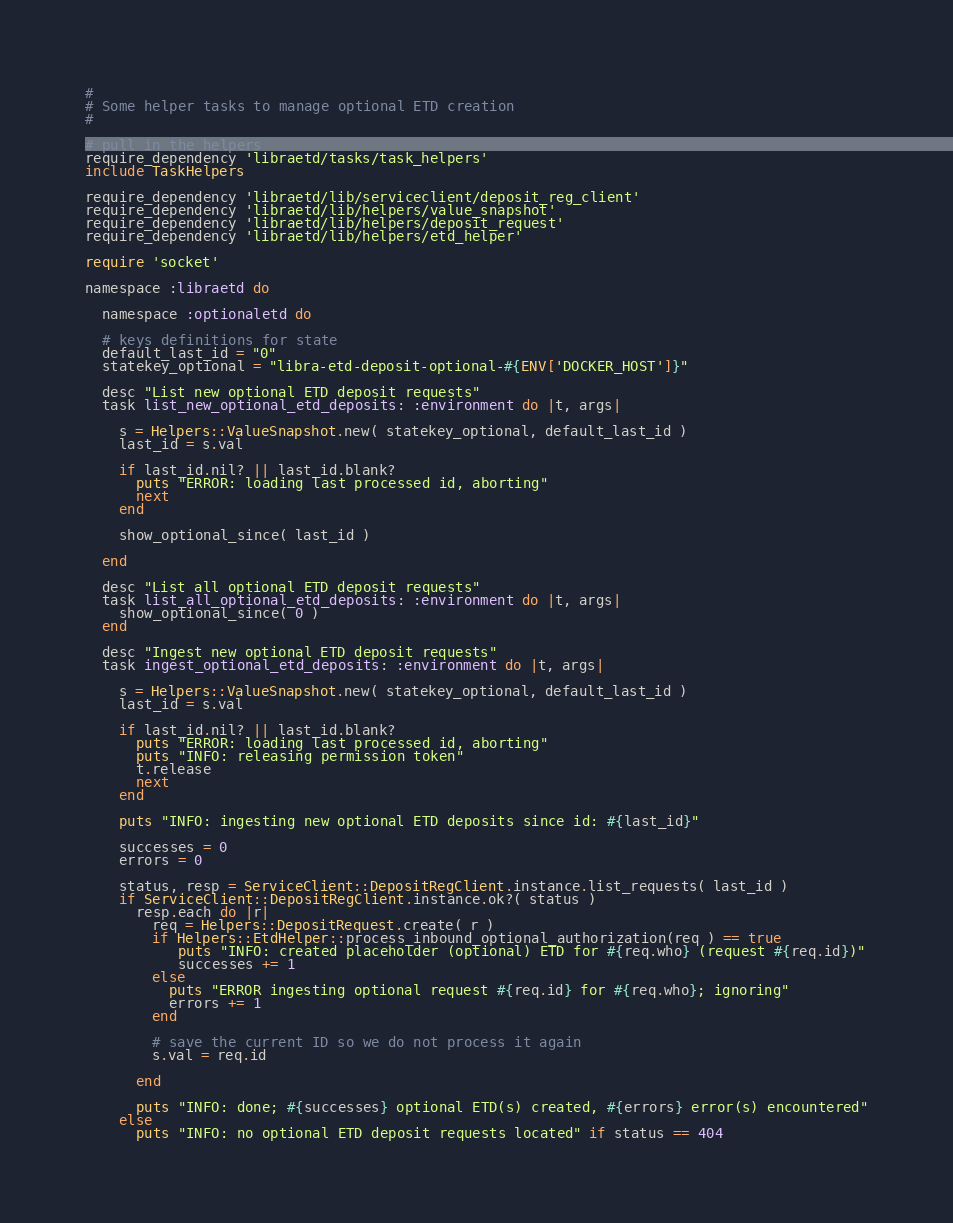Convert code to text. <code><loc_0><loc_0><loc_500><loc_500><_Ruby_>#
# Some helper tasks to manage optional ETD creation
#

# pull in the helpers
require_dependency 'libraetd/tasks/task_helpers'
include TaskHelpers

require_dependency 'libraetd/lib/serviceclient/deposit_reg_client'
require_dependency 'libraetd/lib/helpers/value_snapshot'
require_dependency 'libraetd/lib/helpers/deposit_request'
require_dependency 'libraetd/lib/helpers/etd_helper'

require 'socket'

namespace :libraetd do

  namespace :optionaletd do

  # keys definitions for state
  default_last_id = "0"
  statekey_optional = "libra-etd-deposit-optional-#{ENV['DOCKER_HOST']}"

  desc "List new optional ETD deposit requests"
  task list_new_optional_etd_deposits: :environment do |t, args|

    s = Helpers::ValueSnapshot.new( statekey_optional, default_last_id )
    last_id = s.val

    if last_id.nil? || last_id.blank?
      puts "ERROR: loading last processed id, aborting"
      next
    end

    show_optional_since( last_id )

  end

  desc "List all optional ETD deposit requests"
  task list_all_optional_etd_deposits: :environment do |t, args|
    show_optional_since( 0 )
  end

  desc "Ingest new optional ETD deposit requests"
  task ingest_optional_etd_deposits: :environment do |t, args|

    s = Helpers::ValueSnapshot.new( statekey_optional, default_last_id )
    last_id = s.val

    if last_id.nil? || last_id.blank?
      puts "ERROR: loading last processed id, aborting"
      puts "INFO: releasing permission token"
      t.release
      next
    end

    puts "INFO: ingesting new optional ETD deposits since id: #{last_id}"

    successes = 0
    errors = 0

    status, resp = ServiceClient::DepositRegClient.instance.list_requests( last_id )
    if ServiceClient::DepositRegClient.instance.ok?( status )
      resp.each do |r|
        req = Helpers::DepositRequest.create( r )
        if Helpers::EtdHelper::process_inbound_optional_authorization(req ) == true
           puts "INFO: created placeholder (optional) ETD for #{req.who} (request #{req.id})"
           successes += 1
        else
          puts "ERROR ingesting optional request #{req.id} for #{req.who}; ignoring"
          errors += 1
        end

        # save the current ID so we do not process it again
        s.val = req.id

      end

      puts "INFO: done; #{successes} optional ETD(s) created, #{errors} error(s) encountered"
    else
      puts "INFO: no optional ETD deposit requests located" if status == 404</code> 